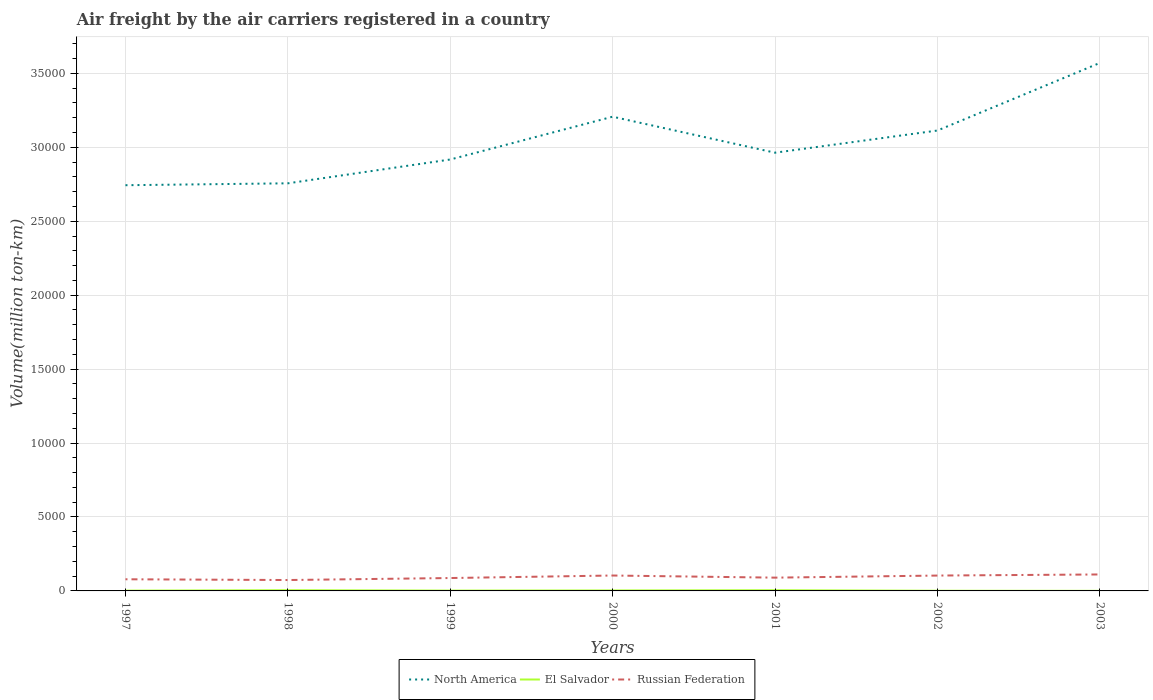Across all years, what is the maximum volume of the air carriers in North America?
Your answer should be compact. 2.74e+04. In which year was the volume of the air carriers in North America maximum?
Give a very brief answer. 1997. What is the total volume of the air carriers in North America in the graph?
Make the answer very short. -4504.49. What is the difference between the highest and the second highest volume of the air carriers in Russian Federation?
Provide a succinct answer. 376.88. Is the volume of the air carriers in North America strictly greater than the volume of the air carriers in El Salvador over the years?
Ensure brevity in your answer.  No. What is the difference between two consecutive major ticks on the Y-axis?
Provide a short and direct response. 5000. Does the graph contain grids?
Your response must be concise. Yes. What is the title of the graph?
Make the answer very short. Air freight by the air carriers registered in a country. What is the label or title of the Y-axis?
Ensure brevity in your answer.  Volume(million ton-km). What is the Volume(million ton-km) of North America in 1997?
Provide a short and direct response. 2.74e+04. What is the Volume(million ton-km) in El Salvador in 1997?
Provide a short and direct response. 19.3. What is the Volume(million ton-km) in Russian Federation in 1997?
Your response must be concise. 788.3. What is the Volume(million ton-km) of North America in 1998?
Ensure brevity in your answer.  2.76e+04. What is the Volume(million ton-km) of Russian Federation in 1998?
Your answer should be compact. 736.5. What is the Volume(million ton-km) in North America in 1999?
Keep it short and to the point. 2.92e+04. What is the Volume(million ton-km) in El Salvador in 1999?
Ensure brevity in your answer.  21.9. What is the Volume(million ton-km) of Russian Federation in 1999?
Your answer should be very brief. 871.8. What is the Volume(million ton-km) in North America in 2000?
Your answer should be compact. 3.21e+04. What is the Volume(million ton-km) in El Salvador in 2000?
Your response must be concise. 31.16. What is the Volume(million ton-km) of Russian Federation in 2000?
Keep it short and to the point. 1041.41. What is the Volume(million ton-km) in North America in 2001?
Provide a short and direct response. 2.96e+04. What is the Volume(million ton-km) of El Salvador in 2001?
Make the answer very short. 46.88. What is the Volume(million ton-km) of Russian Federation in 2001?
Your answer should be very brief. 897.64. What is the Volume(million ton-km) of North America in 2002?
Provide a succinct answer. 3.11e+04. What is the Volume(million ton-km) in Russian Federation in 2002?
Your answer should be very brief. 1039.06. What is the Volume(million ton-km) in North America in 2003?
Provide a succinct answer. 3.57e+04. What is the Volume(million ton-km) in El Salvador in 2003?
Ensure brevity in your answer.  4.8. What is the Volume(million ton-km) of Russian Federation in 2003?
Your answer should be compact. 1113.38. Across all years, what is the maximum Volume(million ton-km) in North America?
Your response must be concise. 3.57e+04. Across all years, what is the maximum Volume(million ton-km) of El Salvador?
Your answer should be very brief. 47. Across all years, what is the maximum Volume(million ton-km) in Russian Federation?
Ensure brevity in your answer.  1113.38. Across all years, what is the minimum Volume(million ton-km) in North America?
Provide a succinct answer. 2.74e+04. Across all years, what is the minimum Volume(million ton-km) in El Salvador?
Provide a short and direct response. 4.8. Across all years, what is the minimum Volume(million ton-km) of Russian Federation?
Ensure brevity in your answer.  736.5. What is the total Volume(million ton-km) in North America in the graph?
Make the answer very short. 2.13e+05. What is the total Volume(million ton-km) of El Salvador in the graph?
Ensure brevity in your answer.  182.64. What is the total Volume(million ton-km) of Russian Federation in the graph?
Your answer should be compact. 6488.09. What is the difference between the Volume(million ton-km) in North America in 1997 and that in 1998?
Offer a terse response. -128.3. What is the difference between the Volume(million ton-km) in El Salvador in 1997 and that in 1998?
Provide a succinct answer. -27.7. What is the difference between the Volume(million ton-km) of Russian Federation in 1997 and that in 1998?
Keep it short and to the point. 51.8. What is the difference between the Volume(million ton-km) in North America in 1997 and that in 1999?
Provide a succinct answer. -1738.5. What is the difference between the Volume(million ton-km) in Russian Federation in 1997 and that in 1999?
Your answer should be very brief. -83.5. What is the difference between the Volume(million ton-km) of North America in 1997 and that in 2000?
Your answer should be very brief. -4632.79. What is the difference between the Volume(million ton-km) of El Salvador in 1997 and that in 2000?
Ensure brevity in your answer.  -11.86. What is the difference between the Volume(million ton-km) in Russian Federation in 1997 and that in 2000?
Your answer should be compact. -253.11. What is the difference between the Volume(million ton-km) in North America in 1997 and that in 2001?
Your answer should be very brief. -2199.08. What is the difference between the Volume(million ton-km) of El Salvador in 1997 and that in 2001?
Offer a terse response. -27.58. What is the difference between the Volume(million ton-km) in Russian Federation in 1997 and that in 2001?
Offer a very short reply. -109.34. What is the difference between the Volume(million ton-km) of North America in 1997 and that in 2002?
Ensure brevity in your answer.  -3697.41. What is the difference between the Volume(million ton-km) of Russian Federation in 1997 and that in 2002?
Make the answer very short. -250.76. What is the difference between the Volume(million ton-km) of North America in 1997 and that in 2003?
Make the answer very short. -8266.55. What is the difference between the Volume(million ton-km) of El Salvador in 1997 and that in 2003?
Keep it short and to the point. 14.5. What is the difference between the Volume(million ton-km) in Russian Federation in 1997 and that in 2003?
Your answer should be compact. -325.08. What is the difference between the Volume(million ton-km) in North America in 1998 and that in 1999?
Make the answer very short. -1610.2. What is the difference between the Volume(million ton-km) in El Salvador in 1998 and that in 1999?
Your response must be concise. 25.1. What is the difference between the Volume(million ton-km) in Russian Federation in 1998 and that in 1999?
Offer a terse response. -135.3. What is the difference between the Volume(million ton-km) of North America in 1998 and that in 2000?
Give a very brief answer. -4504.49. What is the difference between the Volume(million ton-km) in El Salvador in 1998 and that in 2000?
Provide a succinct answer. 15.84. What is the difference between the Volume(million ton-km) of Russian Federation in 1998 and that in 2000?
Offer a terse response. -304.91. What is the difference between the Volume(million ton-km) of North America in 1998 and that in 2001?
Keep it short and to the point. -2070.78. What is the difference between the Volume(million ton-km) of El Salvador in 1998 and that in 2001?
Ensure brevity in your answer.  0.12. What is the difference between the Volume(million ton-km) in Russian Federation in 1998 and that in 2001?
Offer a very short reply. -161.14. What is the difference between the Volume(million ton-km) of North America in 1998 and that in 2002?
Offer a very short reply. -3569.11. What is the difference between the Volume(million ton-km) in El Salvador in 1998 and that in 2002?
Provide a short and direct response. 35.4. What is the difference between the Volume(million ton-km) of Russian Federation in 1998 and that in 2002?
Offer a very short reply. -302.56. What is the difference between the Volume(million ton-km) in North America in 1998 and that in 2003?
Your answer should be very brief. -8138.25. What is the difference between the Volume(million ton-km) of El Salvador in 1998 and that in 2003?
Ensure brevity in your answer.  42.2. What is the difference between the Volume(million ton-km) of Russian Federation in 1998 and that in 2003?
Offer a terse response. -376.88. What is the difference between the Volume(million ton-km) of North America in 1999 and that in 2000?
Provide a succinct answer. -2894.29. What is the difference between the Volume(million ton-km) of El Salvador in 1999 and that in 2000?
Ensure brevity in your answer.  -9.26. What is the difference between the Volume(million ton-km) of Russian Federation in 1999 and that in 2000?
Ensure brevity in your answer.  -169.61. What is the difference between the Volume(million ton-km) in North America in 1999 and that in 2001?
Your answer should be compact. -460.58. What is the difference between the Volume(million ton-km) in El Salvador in 1999 and that in 2001?
Your answer should be very brief. -24.98. What is the difference between the Volume(million ton-km) of Russian Federation in 1999 and that in 2001?
Provide a succinct answer. -25.84. What is the difference between the Volume(million ton-km) of North America in 1999 and that in 2002?
Give a very brief answer. -1958.91. What is the difference between the Volume(million ton-km) in Russian Federation in 1999 and that in 2002?
Provide a succinct answer. -167.26. What is the difference between the Volume(million ton-km) in North America in 1999 and that in 2003?
Give a very brief answer. -6528.05. What is the difference between the Volume(million ton-km) in El Salvador in 1999 and that in 2003?
Make the answer very short. 17.1. What is the difference between the Volume(million ton-km) of Russian Federation in 1999 and that in 2003?
Offer a terse response. -241.58. What is the difference between the Volume(million ton-km) of North America in 2000 and that in 2001?
Your response must be concise. 2433.71. What is the difference between the Volume(million ton-km) of El Salvador in 2000 and that in 2001?
Give a very brief answer. -15.73. What is the difference between the Volume(million ton-km) of Russian Federation in 2000 and that in 2001?
Keep it short and to the point. 143.77. What is the difference between the Volume(million ton-km) of North America in 2000 and that in 2002?
Ensure brevity in your answer.  935.38. What is the difference between the Volume(million ton-km) in El Salvador in 2000 and that in 2002?
Give a very brief answer. 19.56. What is the difference between the Volume(million ton-km) of Russian Federation in 2000 and that in 2002?
Keep it short and to the point. 2.35. What is the difference between the Volume(million ton-km) of North America in 2000 and that in 2003?
Make the answer very short. -3633.76. What is the difference between the Volume(million ton-km) in El Salvador in 2000 and that in 2003?
Your answer should be compact. 26.36. What is the difference between the Volume(million ton-km) of Russian Federation in 2000 and that in 2003?
Make the answer very short. -71.97. What is the difference between the Volume(million ton-km) in North America in 2001 and that in 2002?
Offer a very short reply. -1498.33. What is the difference between the Volume(million ton-km) in El Salvador in 2001 and that in 2002?
Make the answer very short. 35.28. What is the difference between the Volume(million ton-km) of Russian Federation in 2001 and that in 2002?
Ensure brevity in your answer.  -141.43. What is the difference between the Volume(million ton-km) of North America in 2001 and that in 2003?
Your answer should be very brief. -6067.47. What is the difference between the Volume(million ton-km) of El Salvador in 2001 and that in 2003?
Offer a terse response. 42.09. What is the difference between the Volume(million ton-km) of Russian Federation in 2001 and that in 2003?
Offer a very short reply. -215.74. What is the difference between the Volume(million ton-km) of North America in 2002 and that in 2003?
Keep it short and to the point. -4569.14. What is the difference between the Volume(million ton-km) in El Salvador in 2002 and that in 2003?
Keep it short and to the point. 6.8. What is the difference between the Volume(million ton-km) of Russian Federation in 2002 and that in 2003?
Your answer should be very brief. -74.32. What is the difference between the Volume(million ton-km) in North America in 1997 and the Volume(million ton-km) in El Salvador in 1998?
Keep it short and to the point. 2.74e+04. What is the difference between the Volume(million ton-km) of North America in 1997 and the Volume(million ton-km) of Russian Federation in 1998?
Provide a short and direct response. 2.67e+04. What is the difference between the Volume(million ton-km) of El Salvador in 1997 and the Volume(million ton-km) of Russian Federation in 1998?
Offer a terse response. -717.2. What is the difference between the Volume(million ton-km) of North America in 1997 and the Volume(million ton-km) of El Salvador in 1999?
Give a very brief answer. 2.74e+04. What is the difference between the Volume(million ton-km) of North America in 1997 and the Volume(million ton-km) of Russian Federation in 1999?
Provide a succinct answer. 2.66e+04. What is the difference between the Volume(million ton-km) in El Salvador in 1997 and the Volume(million ton-km) in Russian Federation in 1999?
Your answer should be very brief. -852.5. What is the difference between the Volume(million ton-km) of North America in 1997 and the Volume(million ton-km) of El Salvador in 2000?
Make the answer very short. 2.74e+04. What is the difference between the Volume(million ton-km) of North America in 1997 and the Volume(million ton-km) of Russian Federation in 2000?
Provide a short and direct response. 2.64e+04. What is the difference between the Volume(million ton-km) in El Salvador in 1997 and the Volume(million ton-km) in Russian Federation in 2000?
Your response must be concise. -1022.11. What is the difference between the Volume(million ton-km) of North America in 1997 and the Volume(million ton-km) of El Salvador in 2001?
Ensure brevity in your answer.  2.74e+04. What is the difference between the Volume(million ton-km) in North America in 1997 and the Volume(million ton-km) in Russian Federation in 2001?
Keep it short and to the point. 2.65e+04. What is the difference between the Volume(million ton-km) of El Salvador in 1997 and the Volume(million ton-km) of Russian Federation in 2001?
Ensure brevity in your answer.  -878.34. What is the difference between the Volume(million ton-km) of North America in 1997 and the Volume(million ton-km) of El Salvador in 2002?
Provide a succinct answer. 2.74e+04. What is the difference between the Volume(million ton-km) of North America in 1997 and the Volume(million ton-km) of Russian Federation in 2002?
Your response must be concise. 2.64e+04. What is the difference between the Volume(million ton-km) in El Salvador in 1997 and the Volume(million ton-km) in Russian Federation in 2002?
Make the answer very short. -1019.76. What is the difference between the Volume(million ton-km) in North America in 1997 and the Volume(million ton-km) in El Salvador in 2003?
Give a very brief answer. 2.74e+04. What is the difference between the Volume(million ton-km) of North America in 1997 and the Volume(million ton-km) of Russian Federation in 2003?
Offer a very short reply. 2.63e+04. What is the difference between the Volume(million ton-km) in El Salvador in 1997 and the Volume(million ton-km) in Russian Federation in 2003?
Keep it short and to the point. -1094.08. What is the difference between the Volume(million ton-km) in North America in 1998 and the Volume(million ton-km) in El Salvador in 1999?
Provide a succinct answer. 2.75e+04. What is the difference between the Volume(million ton-km) of North America in 1998 and the Volume(million ton-km) of Russian Federation in 1999?
Provide a succinct answer. 2.67e+04. What is the difference between the Volume(million ton-km) in El Salvador in 1998 and the Volume(million ton-km) in Russian Federation in 1999?
Provide a succinct answer. -824.8. What is the difference between the Volume(million ton-km) in North America in 1998 and the Volume(million ton-km) in El Salvador in 2000?
Your answer should be compact. 2.75e+04. What is the difference between the Volume(million ton-km) of North America in 1998 and the Volume(million ton-km) of Russian Federation in 2000?
Provide a short and direct response. 2.65e+04. What is the difference between the Volume(million ton-km) in El Salvador in 1998 and the Volume(million ton-km) in Russian Federation in 2000?
Make the answer very short. -994.41. What is the difference between the Volume(million ton-km) in North America in 1998 and the Volume(million ton-km) in El Salvador in 2001?
Ensure brevity in your answer.  2.75e+04. What is the difference between the Volume(million ton-km) in North America in 1998 and the Volume(million ton-km) in Russian Federation in 2001?
Your response must be concise. 2.67e+04. What is the difference between the Volume(million ton-km) of El Salvador in 1998 and the Volume(million ton-km) of Russian Federation in 2001?
Ensure brevity in your answer.  -850.64. What is the difference between the Volume(million ton-km) in North America in 1998 and the Volume(million ton-km) in El Salvador in 2002?
Ensure brevity in your answer.  2.76e+04. What is the difference between the Volume(million ton-km) of North America in 1998 and the Volume(million ton-km) of Russian Federation in 2002?
Offer a very short reply. 2.65e+04. What is the difference between the Volume(million ton-km) in El Salvador in 1998 and the Volume(million ton-km) in Russian Federation in 2002?
Ensure brevity in your answer.  -992.06. What is the difference between the Volume(million ton-km) in North America in 1998 and the Volume(million ton-km) in El Salvador in 2003?
Ensure brevity in your answer.  2.76e+04. What is the difference between the Volume(million ton-km) of North America in 1998 and the Volume(million ton-km) of Russian Federation in 2003?
Ensure brevity in your answer.  2.65e+04. What is the difference between the Volume(million ton-km) in El Salvador in 1998 and the Volume(million ton-km) in Russian Federation in 2003?
Keep it short and to the point. -1066.38. What is the difference between the Volume(million ton-km) of North America in 1999 and the Volume(million ton-km) of El Salvador in 2000?
Give a very brief answer. 2.91e+04. What is the difference between the Volume(million ton-km) of North America in 1999 and the Volume(million ton-km) of Russian Federation in 2000?
Offer a very short reply. 2.81e+04. What is the difference between the Volume(million ton-km) in El Salvador in 1999 and the Volume(million ton-km) in Russian Federation in 2000?
Your answer should be compact. -1019.51. What is the difference between the Volume(million ton-km) in North America in 1999 and the Volume(million ton-km) in El Salvador in 2001?
Offer a terse response. 2.91e+04. What is the difference between the Volume(million ton-km) of North America in 1999 and the Volume(million ton-km) of Russian Federation in 2001?
Make the answer very short. 2.83e+04. What is the difference between the Volume(million ton-km) in El Salvador in 1999 and the Volume(million ton-km) in Russian Federation in 2001?
Make the answer very short. -875.74. What is the difference between the Volume(million ton-km) of North America in 1999 and the Volume(million ton-km) of El Salvador in 2002?
Your response must be concise. 2.92e+04. What is the difference between the Volume(million ton-km) in North America in 1999 and the Volume(million ton-km) in Russian Federation in 2002?
Ensure brevity in your answer.  2.81e+04. What is the difference between the Volume(million ton-km) in El Salvador in 1999 and the Volume(million ton-km) in Russian Federation in 2002?
Provide a short and direct response. -1017.16. What is the difference between the Volume(million ton-km) of North America in 1999 and the Volume(million ton-km) of El Salvador in 2003?
Offer a terse response. 2.92e+04. What is the difference between the Volume(million ton-km) in North America in 1999 and the Volume(million ton-km) in Russian Federation in 2003?
Your answer should be compact. 2.81e+04. What is the difference between the Volume(million ton-km) of El Salvador in 1999 and the Volume(million ton-km) of Russian Federation in 2003?
Your answer should be compact. -1091.48. What is the difference between the Volume(million ton-km) of North America in 2000 and the Volume(million ton-km) of El Salvador in 2001?
Keep it short and to the point. 3.20e+04. What is the difference between the Volume(million ton-km) in North America in 2000 and the Volume(million ton-km) in Russian Federation in 2001?
Keep it short and to the point. 3.12e+04. What is the difference between the Volume(million ton-km) of El Salvador in 2000 and the Volume(million ton-km) of Russian Federation in 2001?
Make the answer very short. -866.48. What is the difference between the Volume(million ton-km) in North America in 2000 and the Volume(million ton-km) in El Salvador in 2002?
Your answer should be compact. 3.21e+04. What is the difference between the Volume(million ton-km) in North America in 2000 and the Volume(million ton-km) in Russian Federation in 2002?
Provide a succinct answer. 3.10e+04. What is the difference between the Volume(million ton-km) of El Salvador in 2000 and the Volume(million ton-km) of Russian Federation in 2002?
Provide a succinct answer. -1007.91. What is the difference between the Volume(million ton-km) in North America in 2000 and the Volume(million ton-km) in El Salvador in 2003?
Give a very brief answer. 3.21e+04. What is the difference between the Volume(million ton-km) of North America in 2000 and the Volume(million ton-km) of Russian Federation in 2003?
Give a very brief answer. 3.10e+04. What is the difference between the Volume(million ton-km) of El Salvador in 2000 and the Volume(million ton-km) of Russian Federation in 2003?
Ensure brevity in your answer.  -1082.22. What is the difference between the Volume(million ton-km) of North America in 2001 and the Volume(million ton-km) of El Salvador in 2002?
Make the answer very short. 2.96e+04. What is the difference between the Volume(million ton-km) in North America in 2001 and the Volume(million ton-km) in Russian Federation in 2002?
Give a very brief answer. 2.86e+04. What is the difference between the Volume(million ton-km) in El Salvador in 2001 and the Volume(million ton-km) in Russian Federation in 2002?
Your answer should be compact. -992.18. What is the difference between the Volume(million ton-km) of North America in 2001 and the Volume(million ton-km) of El Salvador in 2003?
Offer a terse response. 2.96e+04. What is the difference between the Volume(million ton-km) in North America in 2001 and the Volume(million ton-km) in Russian Federation in 2003?
Provide a succinct answer. 2.85e+04. What is the difference between the Volume(million ton-km) of El Salvador in 2001 and the Volume(million ton-km) of Russian Federation in 2003?
Offer a very short reply. -1066.5. What is the difference between the Volume(million ton-km) in North America in 2002 and the Volume(million ton-km) in El Salvador in 2003?
Keep it short and to the point. 3.11e+04. What is the difference between the Volume(million ton-km) of North America in 2002 and the Volume(million ton-km) of Russian Federation in 2003?
Give a very brief answer. 3.00e+04. What is the difference between the Volume(million ton-km) of El Salvador in 2002 and the Volume(million ton-km) of Russian Federation in 2003?
Offer a terse response. -1101.78. What is the average Volume(million ton-km) in North America per year?
Offer a very short reply. 3.04e+04. What is the average Volume(million ton-km) of El Salvador per year?
Give a very brief answer. 26.09. What is the average Volume(million ton-km) of Russian Federation per year?
Your response must be concise. 926.87. In the year 1997, what is the difference between the Volume(million ton-km) in North America and Volume(million ton-km) in El Salvador?
Offer a terse response. 2.74e+04. In the year 1997, what is the difference between the Volume(million ton-km) in North America and Volume(million ton-km) in Russian Federation?
Make the answer very short. 2.66e+04. In the year 1997, what is the difference between the Volume(million ton-km) of El Salvador and Volume(million ton-km) of Russian Federation?
Offer a terse response. -769. In the year 1998, what is the difference between the Volume(million ton-km) of North America and Volume(million ton-km) of El Salvador?
Provide a short and direct response. 2.75e+04. In the year 1998, what is the difference between the Volume(million ton-km) of North America and Volume(million ton-km) of Russian Federation?
Ensure brevity in your answer.  2.68e+04. In the year 1998, what is the difference between the Volume(million ton-km) in El Salvador and Volume(million ton-km) in Russian Federation?
Your answer should be very brief. -689.5. In the year 1999, what is the difference between the Volume(million ton-km) of North America and Volume(million ton-km) of El Salvador?
Give a very brief answer. 2.92e+04. In the year 1999, what is the difference between the Volume(million ton-km) of North America and Volume(million ton-km) of Russian Federation?
Offer a very short reply. 2.83e+04. In the year 1999, what is the difference between the Volume(million ton-km) in El Salvador and Volume(million ton-km) in Russian Federation?
Your response must be concise. -849.9. In the year 2000, what is the difference between the Volume(million ton-km) in North America and Volume(million ton-km) in El Salvador?
Provide a short and direct response. 3.20e+04. In the year 2000, what is the difference between the Volume(million ton-km) of North America and Volume(million ton-km) of Russian Federation?
Provide a short and direct response. 3.10e+04. In the year 2000, what is the difference between the Volume(million ton-km) in El Salvador and Volume(million ton-km) in Russian Federation?
Keep it short and to the point. -1010.25. In the year 2001, what is the difference between the Volume(million ton-km) in North America and Volume(million ton-km) in El Salvador?
Offer a terse response. 2.96e+04. In the year 2001, what is the difference between the Volume(million ton-km) of North America and Volume(million ton-km) of Russian Federation?
Provide a short and direct response. 2.87e+04. In the year 2001, what is the difference between the Volume(million ton-km) in El Salvador and Volume(million ton-km) in Russian Federation?
Ensure brevity in your answer.  -850.75. In the year 2002, what is the difference between the Volume(million ton-km) in North America and Volume(million ton-km) in El Salvador?
Offer a terse response. 3.11e+04. In the year 2002, what is the difference between the Volume(million ton-km) of North America and Volume(million ton-km) of Russian Federation?
Provide a short and direct response. 3.01e+04. In the year 2002, what is the difference between the Volume(million ton-km) of El Salvador and Volume(million ton-km) of Russian Federation?
Keep it short and to the point. -1027.46. In the year 2003, what is the difference between the Volume(million ton-km) in North America and Volume(million ton-km) in El Salvador?
Provide a succinct answer. 3.57e+04. In the year 2003, what is the difference between the Volume(million ton-km) of North America and Volume(million ton-km) of Russian Federation?
Give a very brief answer. 3.46e+04. In the year 2003, what is the difference between the Volume(million ton-km) in El Salvador and Volume(million ton-km) in Russian Federation?
Provide a succinct answer. -1108.58. What is the ratio of the Volume(million ton-km) of El Salvador in 1997 to that in 1998?
Offer a terse response. 0.41. What is the ratio of the Volume(million ton-km) in Russian Federation in 1997 to that in 1998?
Provide a short and direct response. 1.07. What is the ratio of the Volume(million ton-km) in North America in 1997 to that in 1999?
Your response must be concise. 0.94. What is the ratio of the Volume(million ton-km) of El Salvador in 1997 to that in 1999?
Give a very brief answer. 0.88. What is the ratio of the Volume(million ton-km) of Russian Federation in 1997 to that in 1999?
Provide a succinct answer. 0.9. What is the ratio of the Volume(million ton-km) of North America in 1997 to that in 2000?
Ensure brevity in your answer.  0.86. What is the ratio of the Volume(million ton-km) of El Salvador in 1997 to that in 2000?
Offer a very short reply. 0.62. What is the ratio of the Volume(million ton-km) of Russian Federation in 1997 to that in 2000?
Keep it short and to the point. 0.76. What is the ratio of the Volume(million ton-km) in North America in 1997 to that in 2001?
Ensure brevity in your answer.  0.93. What is the ratio of the Volume(million ton-km) in El Salvador in 1997 to that in 2001?
Offer a very short reply. 0.41. What is the ratio of the Volume(million ton-km) of Russian Federation in 1997 to that in 2001?
Keep it short and to the point. 0.88. What is the ratio of the Volume(million ton-km) in North America in 1997 to that in 2002?
Offer a very short reply. 0.88. What is the ratio of the Volume(million ton-km) in El Salvador in 1997 to that in 2002?
Ensure brevity in your answer.  1.66. What is the ratio of the Volume(million ton-km) of Russian Federation in 1997 to that in 2002?
Your answer should be compact. 0.76. What is the ratio of the Volume(million ton-km) of North America in 1997 to that in 2003?
Give a very brief answer. 0.77. What is the ratio of the Volume(million ton-km) in El Salvador in 1997 to that in 2003?
Offer a terse response. 4.02. What is the ratio of the Volume(million ton-km) in Russian Federation in 1997 to that in 2003?
Your response must be concise. 0.71. What is the ratio of the Volume(million ton-km) in North America in 1998 to that in 1999?
Ensure brevity in your answer.  0.94. What is the ratio of the Volume(million ton-km) of El Salvador in 1998 to that in 1999?
Ensure brevity in your answer.  2.15. What is the ratio of the Volume(million ton-km) in Russian Federation in 1998 to that in 1999?
Offer a very short reply. 0.84. What is the ratio of the Volume(million ton-km) of North America in 1998 to that in 2000?
Offer a very short reply. 0.86. What is the ratio of the Volume(million ton-km) in El Salvador in 1998 to that in 2000?
Offer a terse response. 1.51. What is the ratio of the Volume(million ton-km) in Russian Federation in 1998 to that in 2000?
Keep it short and to the point. 0.71. What is the ratio of the Volume(million ton-km) of North America in 1998 to that in 2001?
Provide a short and direct response. 0.93. What is the ratio of the Volume(million ton-km) in El Salvador in 1998 to that in 2001?
Your answer should be compact. 1. What is the ratio of the Volume(million ton-km) of Russian Federation in 1998 to that in 2001?
Your answer should be compact. 0.82. What is the ratio of the Volume(million ton-km) in North America in 1998 to that in 2002?
Offer a terse response. 0.89. What is the ratio of the Volume(million ton-km) of El Salvador in 1998 to that in 2002?
Keep it short and to the point. 4.05. What is the ratio of the Volume(million ton-km) in Russian Federation in 1998 to that in 2002?
Your response must be concise. 0.71. What is the ratio of the Volume(million ton-km) in North America in 1998 to that in 2003?
Your response must be concise. 0.77. What is the ratio of the Volume(million ton-km) in El Salvador in 1998 to that in 2003?
Provide a succinct answer. 9.8. What is the ratio of the Volume(million ton-km) in Russian Federation in 1998 to that in 2003?
Keep it short and to the point. 0.66. What is the ratio of the Volume(million ton-km) of North America in 1999 to that in 2000?
Give a very brief answer. 0.91. What is the ratio of the Volume(million ton-km) in El Salvador in 1999 to that in 2000?
Make the answer very short. 0.7. What is the ratio of the Volume(million ton-km) in Russian Federation in 1999 to that in 2000?
Your response must be concise. 0.84. What is the ratio of the Volume(million ton-km) of North America in 1999 to that in 2001?
Your answer should be very brief. 0.98. What is the ratio of the Volume(million ton-km) of El Salvador in 1999 to that in 2001?
Give a very brief answer. 0.47. What is the ratio of the Volume(million ton-km) in Russian Federation in 1999 to that in 2001?
Make the answer very short. 0.97. What is the ratio of the Volume(million ton-km) of North America in 1999 to that in 2002?
Offer a very short reply. 0.94. What is the ratio of the Volume(million ton-km) in El Salvador in 1999 to that in 2002?
Offer a terse response. 1.89. What is the ratio of the Volume(million ton-km) of Russian Federation in 1999 to that in 2002?
Your response must be concise. 0.84. What is the ratio of the Volume(million ton-km) of North America in 1999 to that in 2003?
Offer a very short reply. 0.82. What is the ratio of the Volume(million ton-km) of El Salvador in 1999 to that in 2003?
Offer a terse response. 4.57. What is the ratio of the Volume(million ton-km) in Russian Federation in 1999 to that in 2003?
Your answer should be very brief. 0.78. What is the ratio of the Volume(million ton-km) of North America in 2000 to that in 2001?
Make the answer very short. 1.08. What is the ratio of the Volume(million ton-km) of El Salvador in 2000 to that in 2001?
Make the answer very short. 0.66. What is the ratio of the Volume(million ton-km) of Russian Federation in 2000 to that in 2001?
Give a very brief answer. 1.16. What is the ratio of the Volume(million ton-km) of North America in 2000 to that in 2002?
Give a very brief answer. 1.03. What is the ratio of the Volume(million ton-km) in El Salvador in 2000 to that in 2002?
Your answer should be very brief. 2.69. What is the ratio of the Volume(million ton-km) of Russian Federation in 2000 to that in 2002?
Offer a terse response. 1. What is the ratio of the Volume(million ton-km) of North America in 2000 to that in 2003?
Make the answer very short. 0.9. What is the ratio of the Volume(million ton-km) of El Salvador in 2000 to that in 2003?
Provide a succinct answer. 6.5. What is the ratio of the Volume(million ton-km) of Russian Federation in 2000 to that in 2003?
Provide a short and direct response. 0.94. What is the ratio of the Volume(million ton-km) of North America in 2001 to that in 2002?
Give a very brief answer. 0.95. What is the ratio of the Volume(million ton-km) in El Salvador in 2001 to that in 2002?
Offer a very short reply. 4.04. What is the ratio of the Volume(million ton-km) in Russian Federation in 2001 to that in 2002?
Your answer should be very brief. 0.86. What is the ratio of the Volume(million ton-km) in North America in 2001 to that in 2003?
Your answer should be compact. 0.83. What is the ratio of the Volume(million ton-km) in El Salvador in 2001 to that in 2003?
Provide a short and direct response. 9.77. What is the ratio of the Volume(million ton-km) of Russian Federation in 2001 to that in 2003?
Offer a very short reply. 0.81. What is the ratio of the Volume(million ton-km) in North America in 2002 to that in 2003?
Ensure brevity in your answer.  0.87. What is the ratio of the Volume(million ton-km) in El Salvador in 2002 to that in 2003?
Your answer should be compact. 2.42. What is the difference between the highest and the second highest Volume(million ton-km) of North America?
Your answer should be compact. 3633.76. What is the difference between the highest and the second highest Volume(million ton-km) in El Salvador?
Your answer should be very brief. 0.12. What is the difference between the highest and the second highest Volume(million ton-km) in Russian Federation?
Ensure brevity in your answer.  71.97. What is the difference between the highest and the lowest Volume(million ton-km) in North America?
Your answer should be very brief. 8266.55. What is the difference between the highest and the lowest Volume(million ton-km) in El Salvador?
Provide a short and direct response. 42.2. What is the difference between the highest and the lowest Volume(million ton-km) in Russian Federation?
Your answer should be compact. 376.88. 